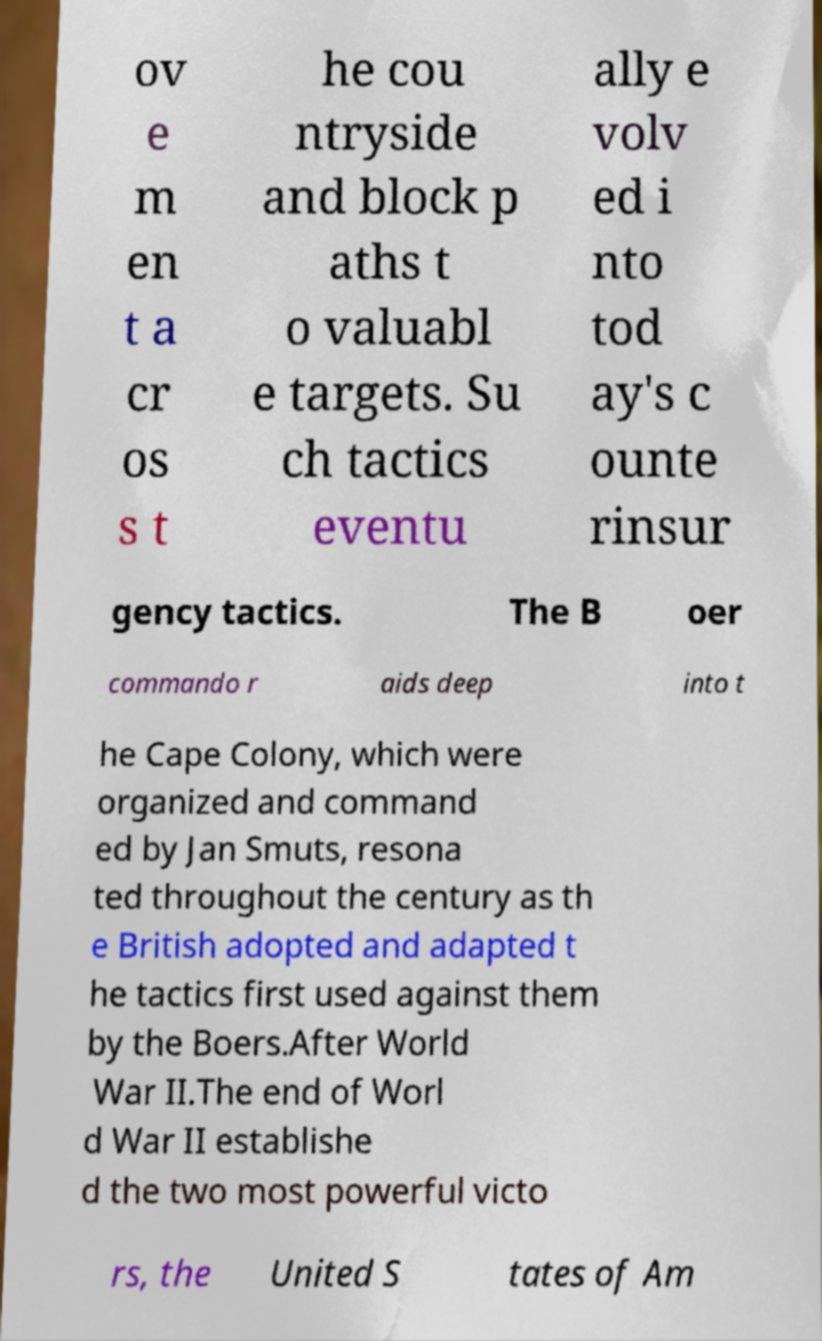I need the written content from this picture converted into text. Can you do that? ov e m en t a cr os s t he cou ntryside and block p aths t o valuabl e targets. Su ch tactics eventu ally e volv ed i nto tod ay's c ounte rinsur gency tactics. The B oer commando r aids deep into t he Cape Colony, which were organized and command ed by Jan Smuts, resona ted throughout the century as th e British adopted and adapted t he tactics first used against them by the Boers.After World War II.The end of Worl d War II establishe d the two most powerful victo rs, the United S tates of Am 